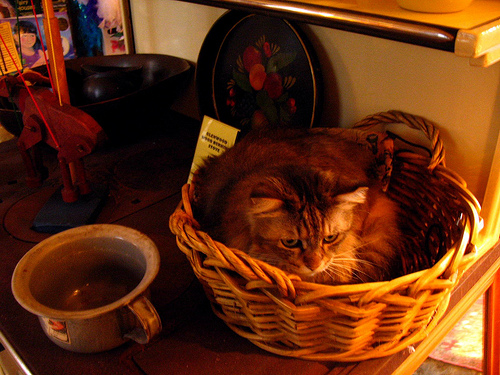<image>
Can you confirm if the cat is in front of the basket? No. The cat is not in front of the basket. The spatial positioning shows a different relationship between these objects. 